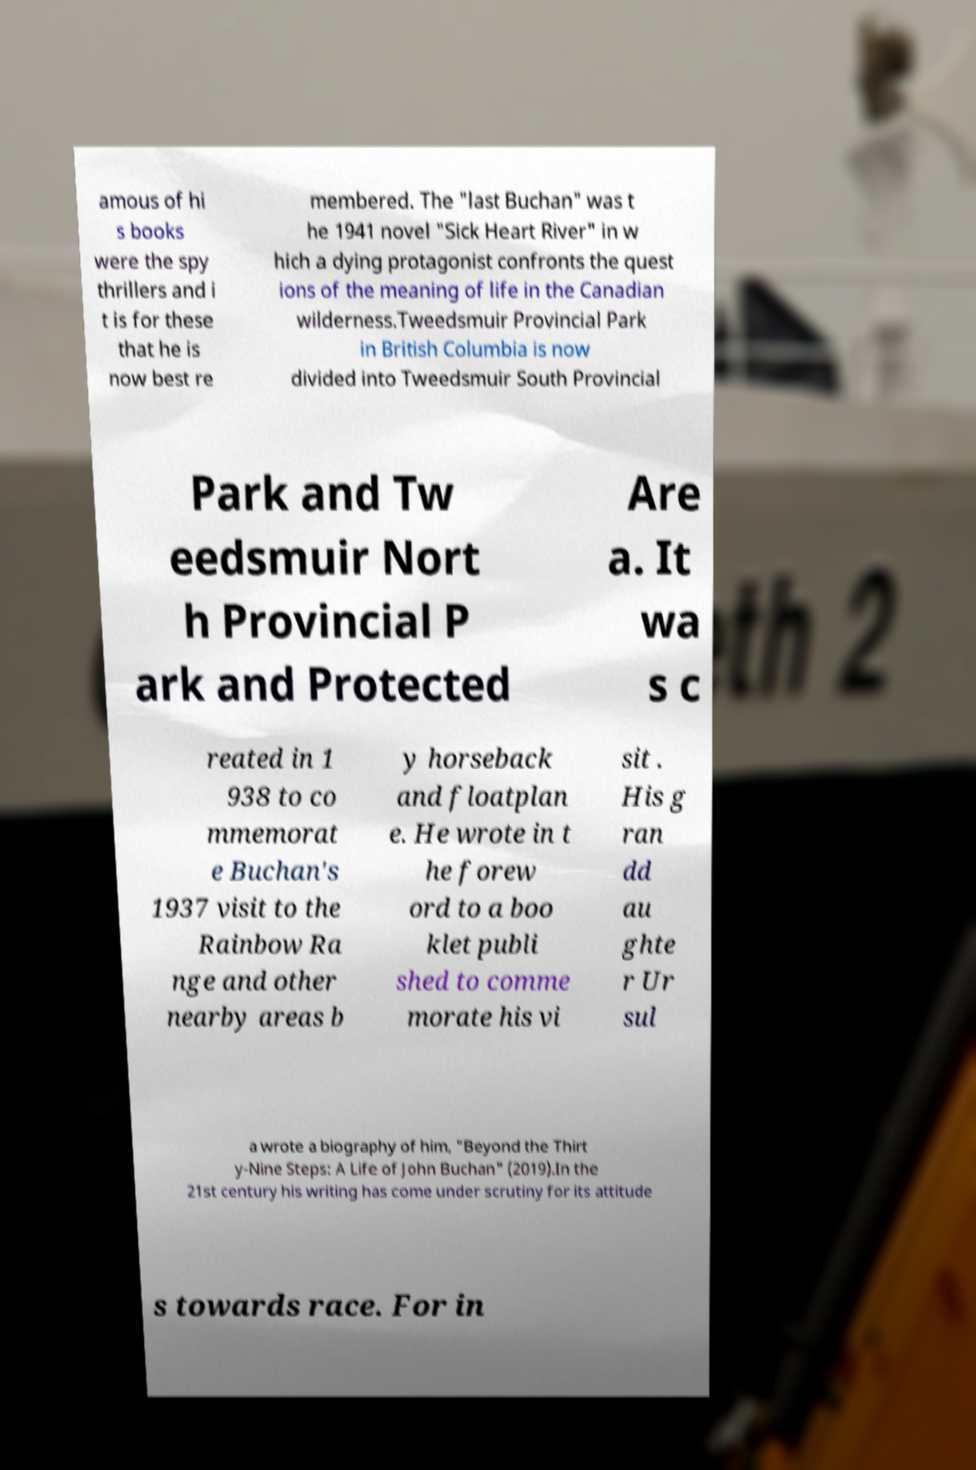For documentation purposes, I need the text within this image transcribed. Could you provide that? amous of hi s books were the spy thrillers and i t is for these that he is now best re membered. The "last Buchan" was t he 1941 novel "Sick Heart River" in w hich a dying protagonist confronts the quest ions of the meaning of life in the Canadian wilderness.Tweedsmuir Provincial Park in British Columbia is now divided into Tweedsmuir South Provincial Park and Tw eedsmuir Nort h Provincial P ark and Protected Are a. It wa s c reated in 1 938 to co mmemorat e Buchan's 1937 visit to the Rainbow Ra nge and other nearby areas b y horseback and floatplan e. He wrote in t he forew ord to a boo klet publi shed to comme morate his vi sit . His g ran dd au ghte r Ur sul a wrote a biography of him, "Beyond the Thirt y-Nine Steps: A Life of John Buchan" (2019).In the 21st century his writing has come under scrutiny for its attitude s towards race. For in 